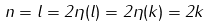Convert formula to latex. <formula><loc_0><loc_0><loc_500><loc_500>n = l = 2 \eta ( l ) = 2 \eta ( k ) = 2 k</formula> 